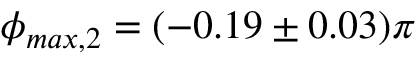<formula> <loc_0><loc_0><loc_500><loc_500>\phi _ { \max , 2 } = ( - 0 . 1 9 \pm 0 . 0 3 ) \pi</formula> 